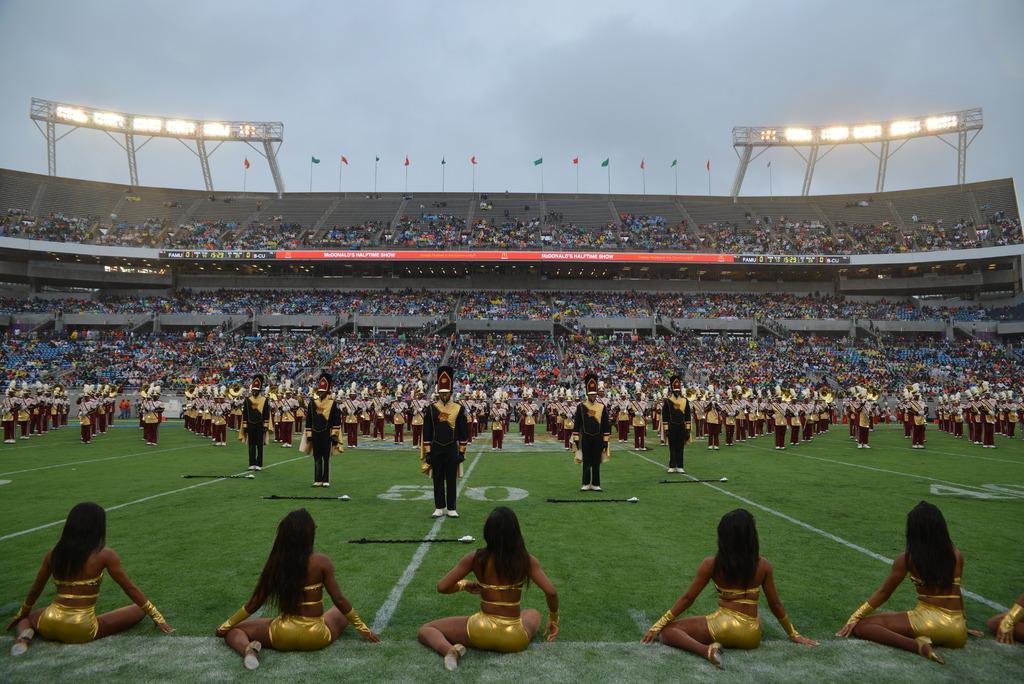Could you give a brief overview of what you see in this image? In this image I can see group of people some are standing and some are sitting. Background I can see few boards in red color, multi color flags, lights and sky is in white color. 